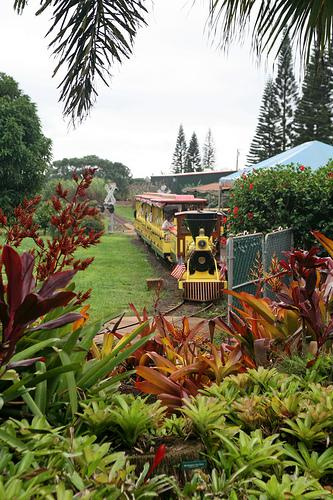Question: what vehicle is that?
Choices:
A. Train.
B. A sedan.
C. A horse-drawn carriage.
D. A truck.
Answer with the letter. Answer: A Question: what is on the ground?
Choices:
A. Snow.
B. Dirt.
C. Gravel.
D. Grass.
Answer with the letter. Answer: D 